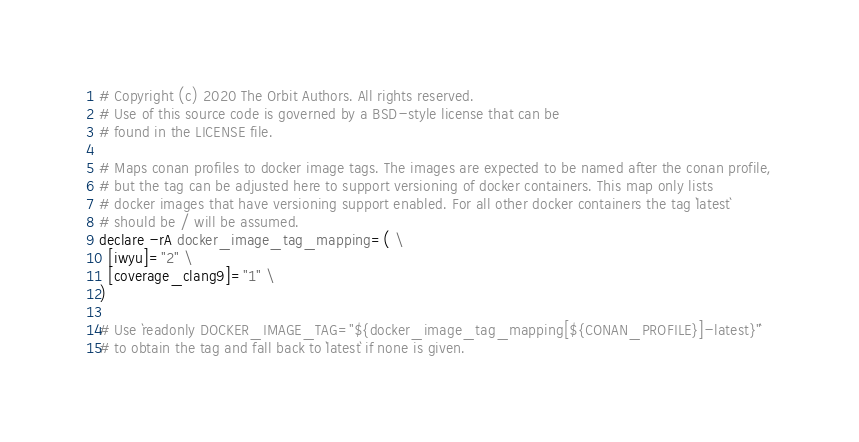Convert code to text. <code><loc_0><loc_0><loc_500><loc_500><_Bash_># Copyright (c) 2020 The Orbit Authors. All rights reserved.
# Use of this source code is governed by a BSD-style license that can be
# found in the LICENSE file.

# Maps conan profiles to docker image tags. The images are expected to be named after the conan profile,
# but the tag can be adjusted here to support versioning of docker containers. This map only lists
# docker images that have versioning support enabled. For all other docker containers the tag `latest`
# should be / will be assumed.
declare -rA docker_image_tag_mapping=( \
  [iwyu]="2" \
  [coverage_clang9]="1" \
)

# Use `readonly DOCKER_IMAGE_TAG="${docker_image_tag_mapping[${CONAN_PROFILE}]-latest}"`
# to obtain the tag and fall back to `latest` if none is given.
</code> 